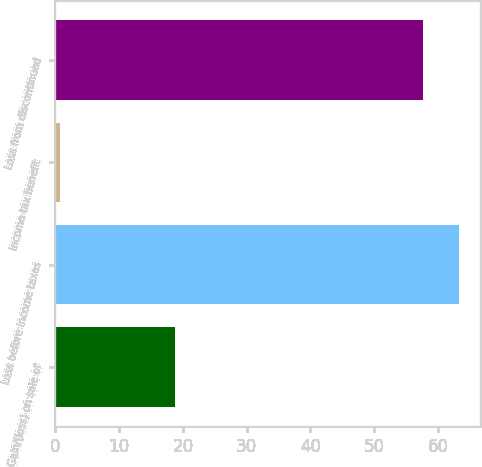Convert chart to OTSL. <chart><loc_0><loc_0><loc_500><loc_500><bar_chart><fcel>Gain/(loss) on sale of<fcel>Loss before income taxes<fcel>Income tax benefit<fcel>Loss from discontinued<nl><fcel>18.7<fcel>63.36<fcel>0.8<fcel>57.6<nl></chart> 